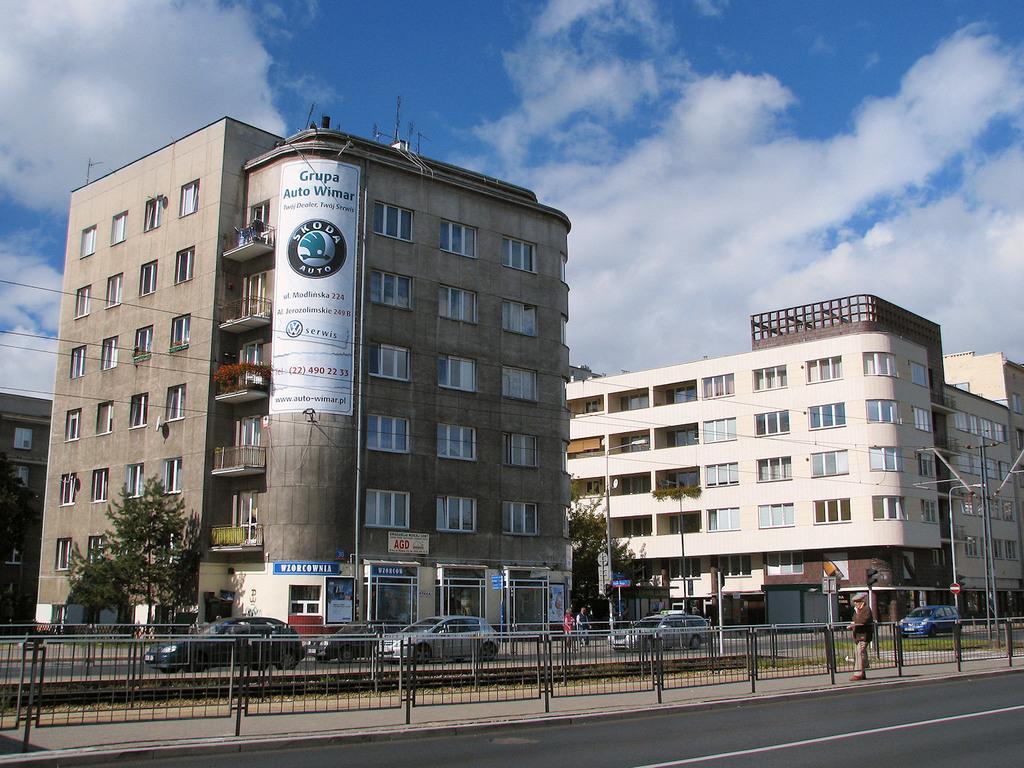Could you give a brief overview of what you see in this image? In the foreground of this image, there is a road, railing, few vehicles moving on the road, a man on the side path. In the background, there are buildings, poles, few trees and cables. On the top, there is the sky and the cloud. 